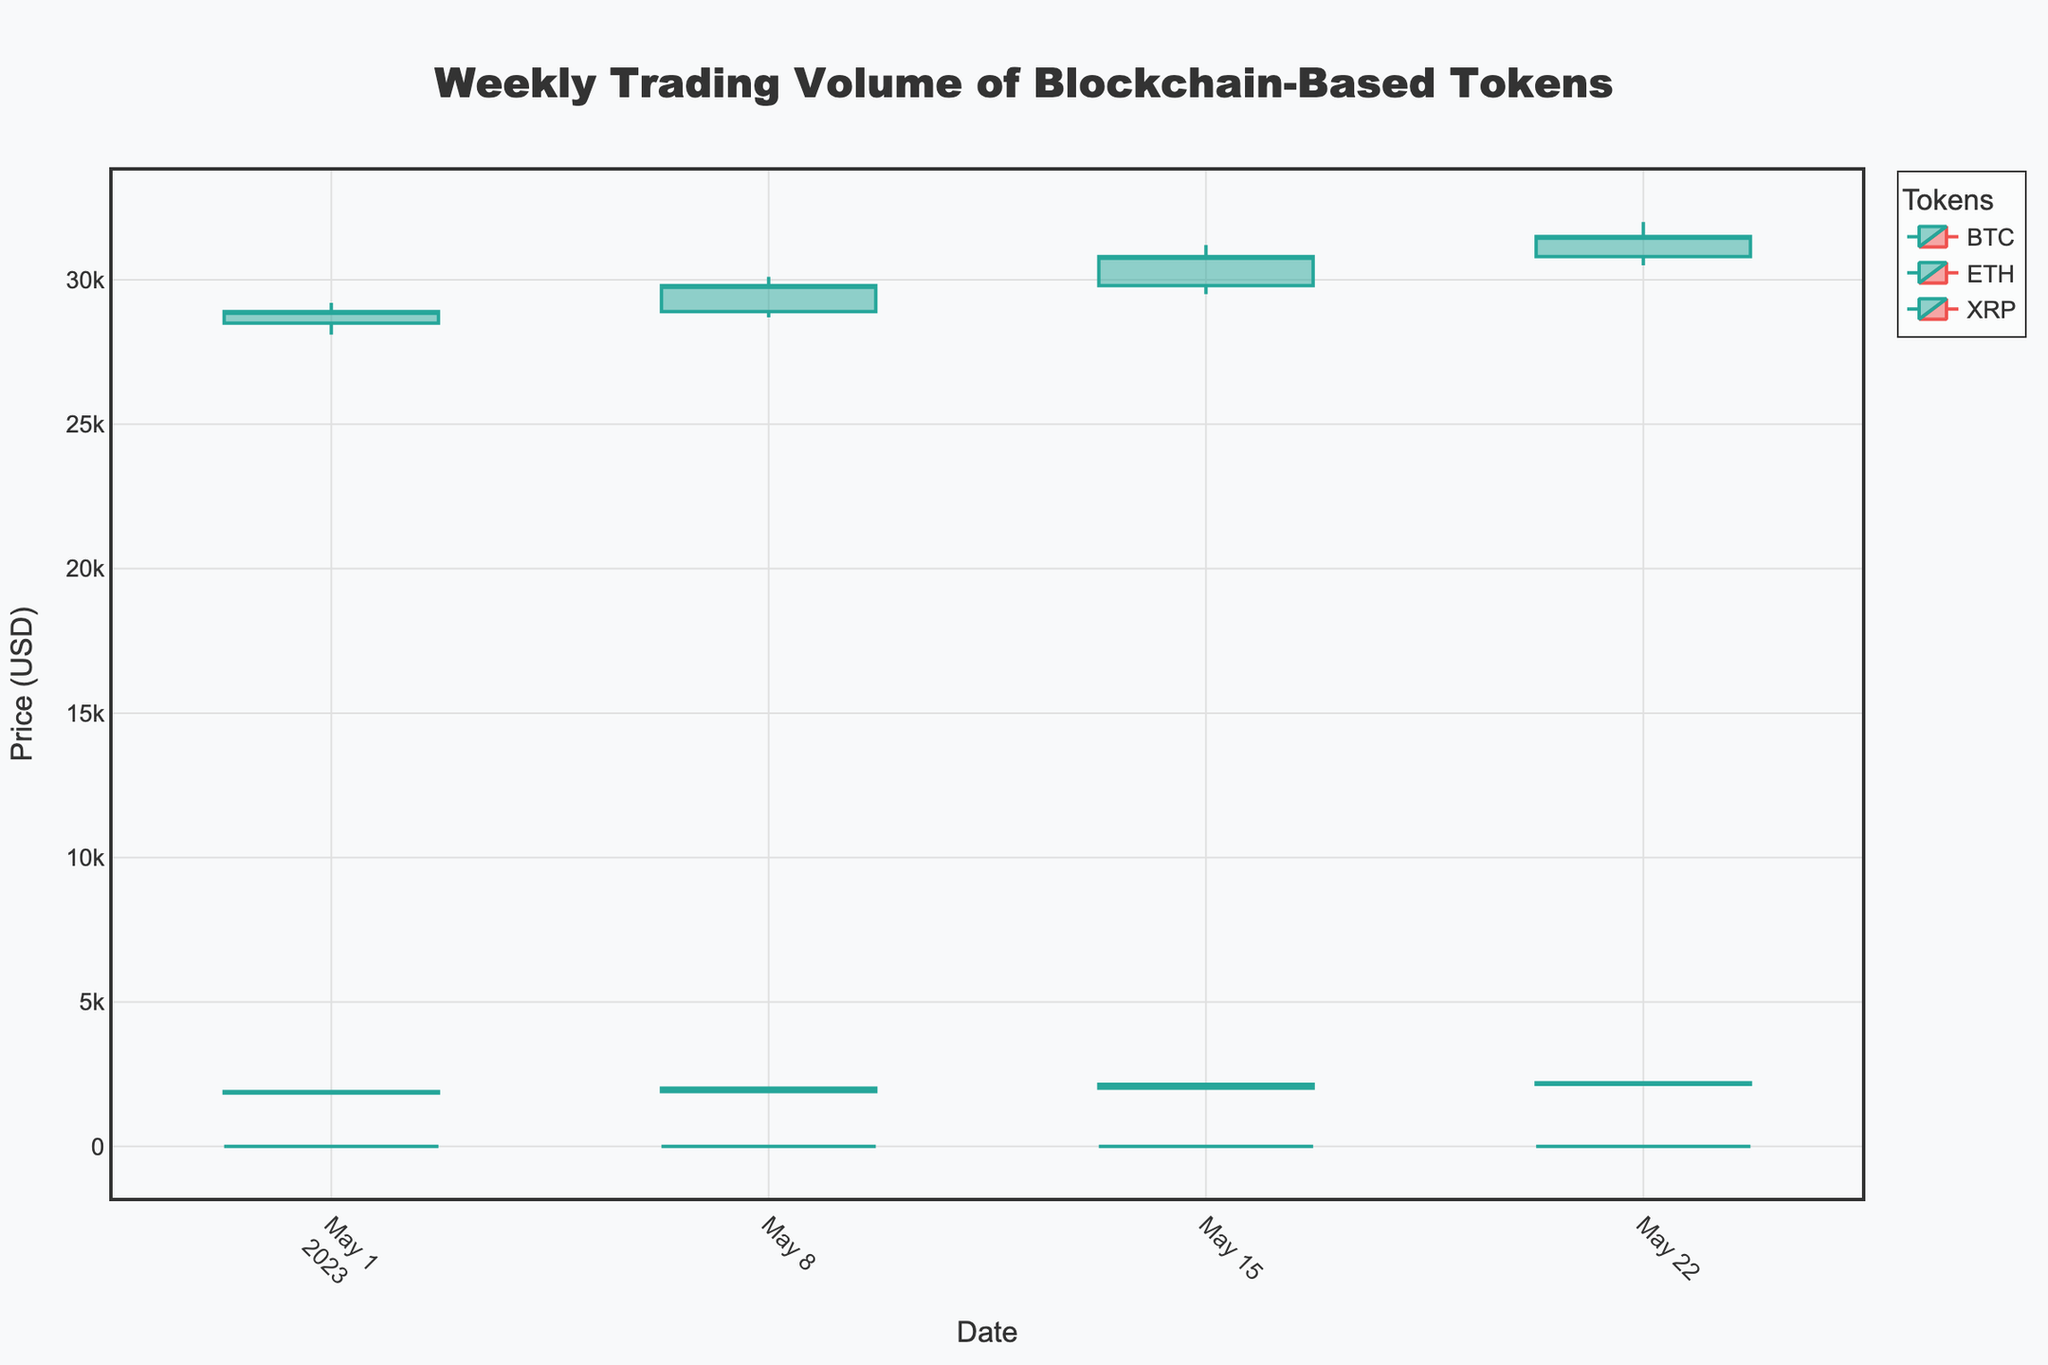what is the title of the chart? The title of the chart is clearly displayed at the top center of the figure.
Answer: Weekly Trading Volume of Blockchain-Based Tokens How many data points are there for each token? Each token appears in every week of the month. There are data points for four weeks, hence each token has four data points.
Answer: 4 Which token had the highest closing price in the last week of May? By examining the close prices for the last week of May (2023-05-22), we see: BTC closes at 31,500, ETH at 2,200, and XRP at 0.57. BTC has the highest closing price.
Answer: BTC What color represents an increasing candlestick? The increasing candlestick lines are characterized by a specific color, which is typically a dark or bright shade to stand out. In this chart, this color is visually distinct.
Answer: Green Compare the trading volume of BTC and ETH in the week of 2023-05-08. Which one was higher? For the week of 2023-05-08, examining the volume data: BTC has 520,000 and ETH has 380,000. BTC has a higher trading volume.
Answer: BTC For which token and date was the lowest price of 0.44 recorded? By filtering visually for the lowest price (Low) of 0.44, it can be matched to the corresponding token and date. Here, it’s Ripple (XRP) on 2023-05-01.
Answer: XRP on 2023-05-01 What is the average closing price of ETH over the month? The closing prices for ETH over the month are 1900, 2020, 2150, 2200. Summing these: 1900 + 2020 + 2150 + 2200 = 8270, and then dividing by the number of data points (4), we get: 8270 / 4.
Answer: 2067.5 By how much did the closing price of BTC increase from the first to the last week? From the first (2023-05-01) to the last week (2023-05-22), BTC's closing prices are 28900 and 31500, respectively. The difference is: 31500 - 28900.
Answer: 2600 Which token showed a consistent increase in its closing price every week? Reviewing the closing prices for each token across all weeks, we observe: BTC has prices 28900, 29800, 30800, 31500. BTC’s closing price increased every week.
Answer: BTC 